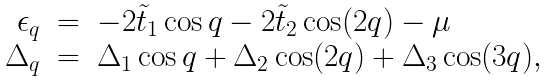Convert formula to latex. <formula><loc_0><loc_0><loc_500><loc_500>\begin{array} { r c l } \epsilon _ { q } & = & - 2 \tilde { t } _ { 1 } \cos q - 2 \tilde { t } _ { 2 } \cos ( 2 q ) - \mu \\ \Delta _ { q } & = & \Delta _ { 1 } \cos q + \Delta _ { 2 } \cos ( 2 q ) + \Delta _ { 3 } \cos ( 3 q ) , \end{array}</formula> 